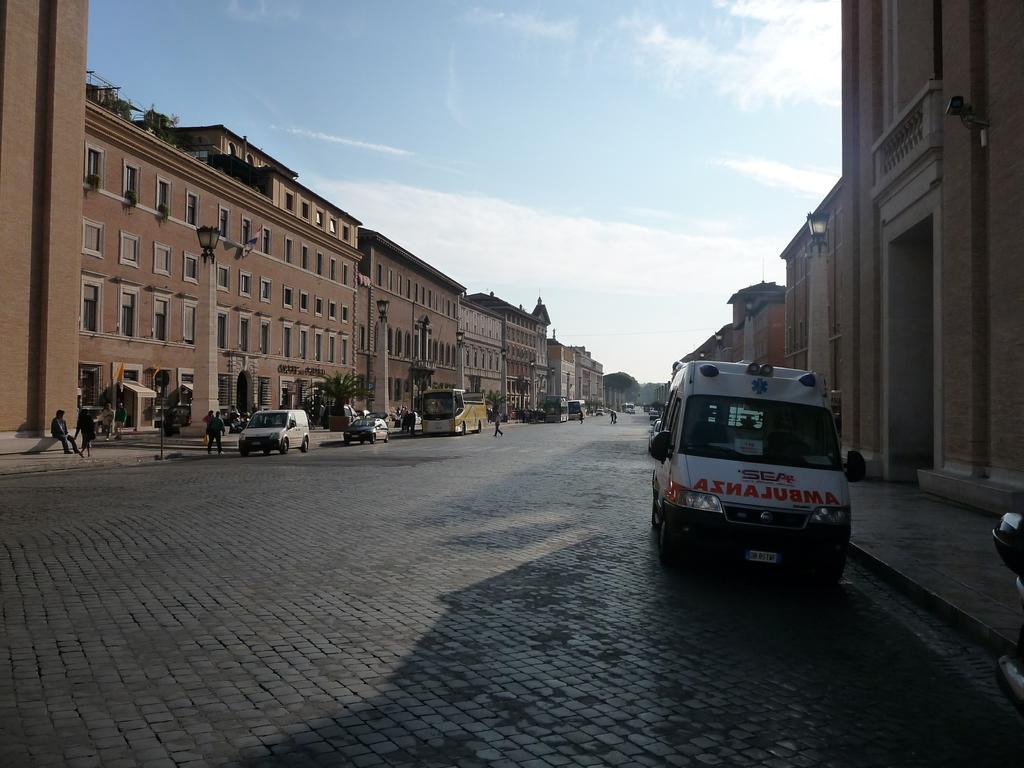Describe this image in one or two sentences. In this image in the center there are vehicles on the road and there are persons standing, sitting and walking. In the background there are buildings and trees and the sky is cloudy. 